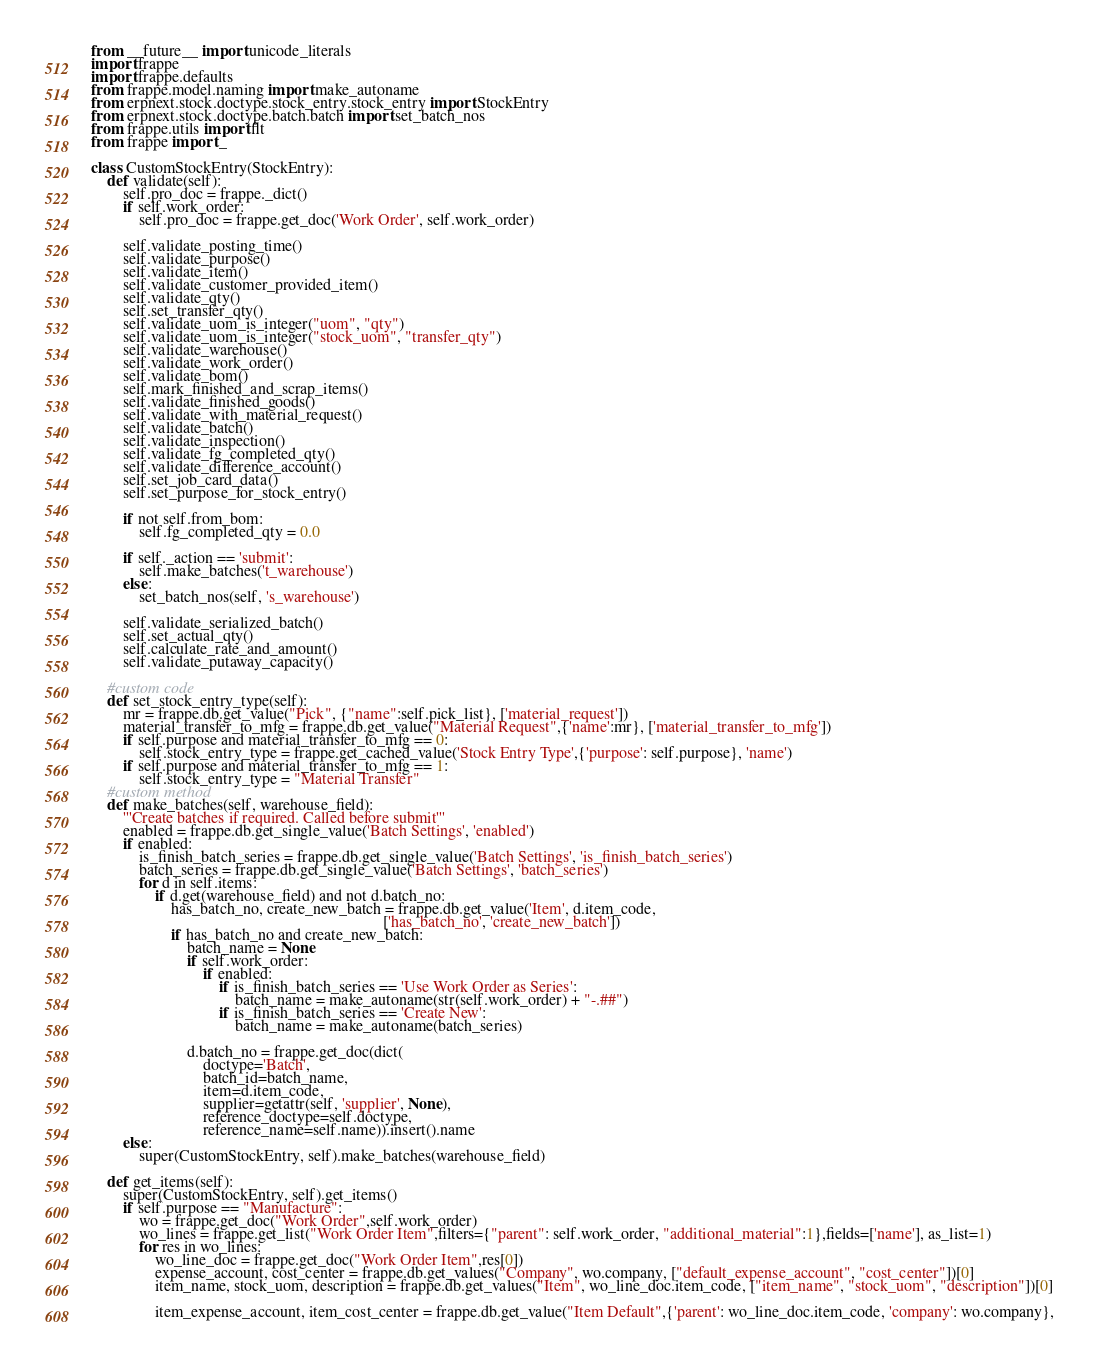<code> <loc_0><loc_0><loc_500><loc_500><_Python_>from __future__ import unicode_literals
import frappe
import frappe.defaults
from frappe.model.naming import make_autoname
from erpnext.stock.doctype.stock_entry.stock_entry import StockEntry
from erpnext.stock.doctype.batch.batch import set_batch_nos
from frappe.utils import flt
from frappe import _

class CustomStockEntry(StockEntry):
    def validate(self):
        self.pro_doc = frappe._dict()
        if self.work_order:
            self.pro_doc = frappe.get_doc('Work Order', self.work_order)

        self.validate_posting_time()
        self.validate_purpose()
        self.validate_item()
        self.validate_customer_provided_item()
        self.validate_qty()
        self.set_transfer_qty()
        self.validate_uom_is_integer("uom", "qty")
        self.validate_uom_is_integer("stock_uom", "transfer_qty")
        self.validate_warehouse()
        self.validate_work_order()
        self.validate_bom()
        self.mark_finished_and_scrap_items()
        self.validate_finished_goods()
        self.validate_with_material_request()
        self.validate_batch()
        self.validate_inspection()
        self.validate_fg_completed_qty()
        self.validate_difference_account()
        self.set_job_card_data()
        self.set_purpose_for_stock_entry()

        if not self.from_bom:
            self.fg_completed_qty = 0.0

        if self._action == 'submit':
            self.make_batches('t_warehouse')
        else:
            set_batch_nos(self, 's_warehouse')

        self.validate_serialized_batch()
        self.set_actual_qty()
        self.calculate_rate_and_amount()
        self.validate_putaway_capacity()
    
    #custom code
    def set_stock_entry_type(self):
        mr = frappe.db.get_value("Pick", {"name":self.pick_list}, ['material_request'])
        material_transfer_to_mfg = frappe.db.get_value("Material Request",{'name':mr}, ['material_transfer_to_mfg'])                                         
        if self.purpose and material_transfer_to_mfg == 0:
            self.stock_entry_type = frappe.get_cached_value('Stock Entry Type',{'purpose': self.purpose}, 'name')
        if self.purpose and material_transfer_to_mfg == 1:
            self.stock_entry_type = "Material Transfer"
    #custom method
    def make_batches(self, warehouse_field):
        '''Create batches if required. Called before submit'''
        enabled = frappe.db.get_single_value('Batch Settings', 'enabled')
        if enabled:
            is_finish_batch_series = frappe.db.get_single_value('Batch Settings', 'is_finish_batch_series')
            batch_series = frappe.db.get_single_value('Batch Settings', 'batch_series')
            for d in self.items:
                if d.get(warehouse_field) and not d.batch_no:
                    has_batch_no, create_new_batch = frappe.db.get_value('Item', d.item_code,
                                                                         ['has_batch_no', 'create_new_batch'])
                    if has_batch_no and create_new_batch:
                        batch_name = None
                        if self.work_order:
                            if enabled:
                                if is_finish_batch_series == 'Use Work Order as Series':
                                    batch_name = make_autoname(str(self.work_order) + "-.##")
                                if is_finish_batch_series == 'Create New':
                                    batch_name = make_autoname(batch_series)
    
                        d.batch_no = frappe.get_doc(dict(
                            doctype='Batch',
                            batch_id=batch_name,
                            item=d.item_code,
                            supplier=getattr(self, 'supplier', None),
                            reference_doctype=self.doctype,
                            reference_name=self.name)).insert().name
        else:
            super(CustomStockEntry, self).make_batches(warehouse_field)

    def get_items(self):
        super(CustomStockEntry, self).get_items()
        if self.purpose == "Manufacture":
            wo = frappe.get_doc("Work Order",self.work_order)
            wo_lines = frappe.get_list("Work Order Item",filters={"parent": self.work_order, "additional_material":1},fields=['name'], as_list=1)
            for res in wo_lines:
                wo_line_doc = frappe.get_doc("Work Order Item",res[0])
                expense_account, cost_center = frappe.db.get_values("Company", wo.company, ["default_expense_account", "cost_center"])[0]
                item_name, stock_uom, description = frappe.db.get_values("Item", wo_line_doc.item_code, ["item_name", "stock_uom", "description"])[0]

                item_expense_account, item_cost_center = frappe.db.get_value("Item Default",{'parent': wo_line_doc.item_code, 'company': wo.company},</code> 